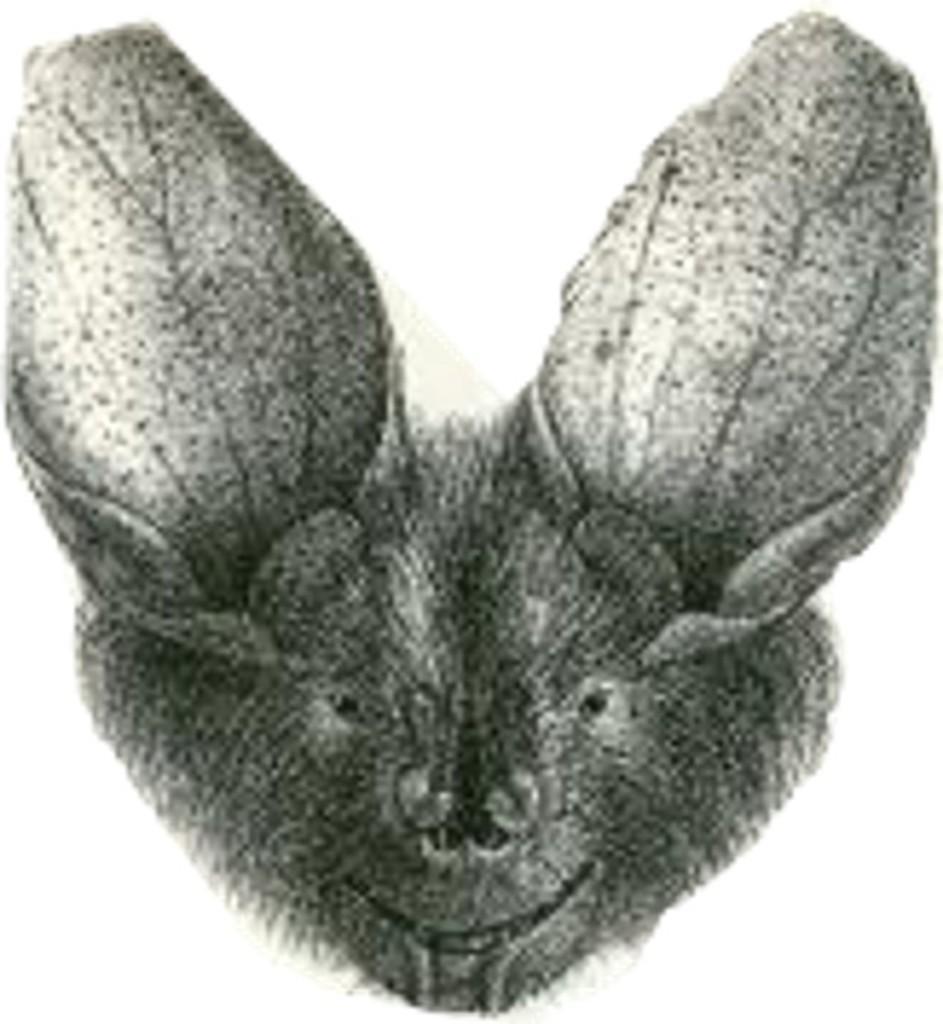Could you give a brief overview of what you see in this image? This is black and white pic. Here we can see an animal. 